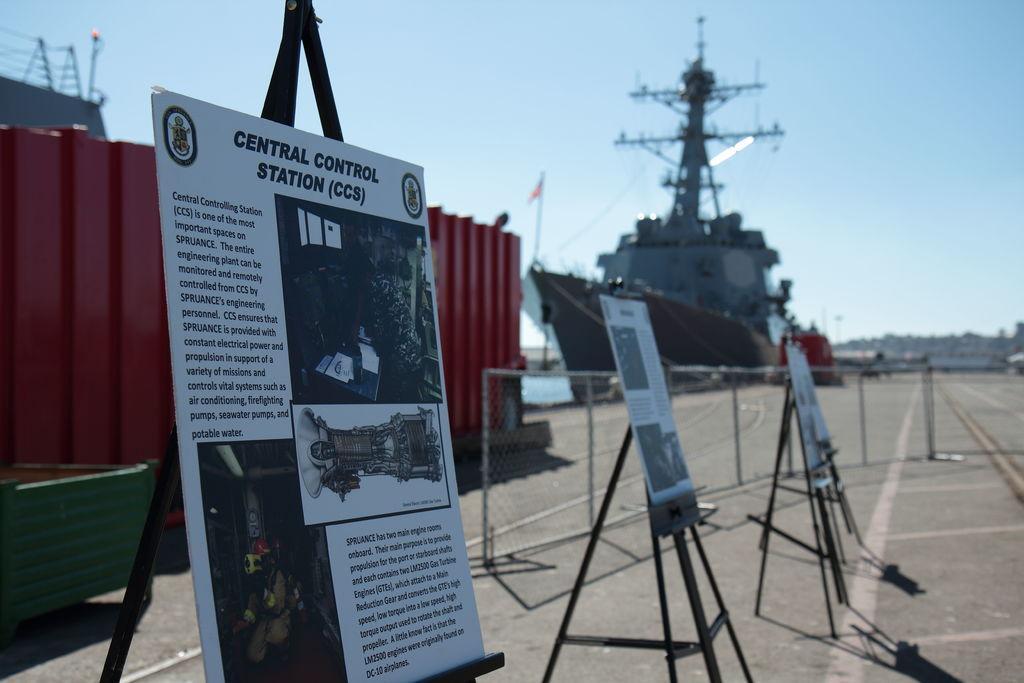Can you describe this image briefly? In the foreground of the image we can boards with some pictures and text are placed on standing kept on the ground. In the center of the image we can see a fence. To the left side of the image we can see a building with poles and a container placed on the ground. In the background, we can see a ship placed in water and the sky. 